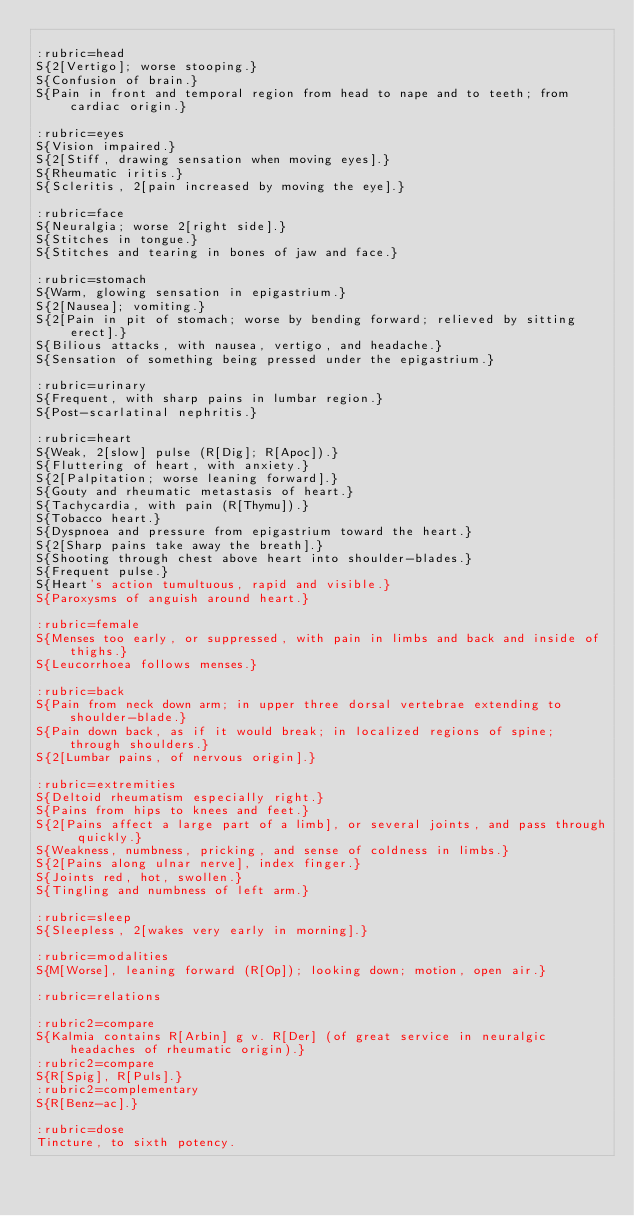<code> <loc_0><loc_0><loc_500><loc_500><_ObjectiveC_>
:rubric=head
S{2[Vertigo]; worse stooping.}
S{Confusion of brain.}
S{Pain in front and temporal region from head to nape and to teeth; from cardiac origin.}

:rubric=eyes
S{Vision impaired.}
S{2[Stiff, drawing sensation when moving eyes].}
S{Rheumatic iritis.}
S{Scleritis, 2[pain increased by moving the eye].}

:rubric=face
S{Neuralgia; worse 2[right side].}
S{Stitches in tongue.}
S{Stitches and tearing in bones of jaw and face.}

:rubric=stomach
S{Warm, glowing sensation in epigastrium.}
S{2[Nausea]; vomiting.}
S{2[Pain in pit of stomach; worse by bending forward; relieved by sitting erect].}
S{Bilious attacks, with nausea, vertigo, and headache.}
S{Sensation of something being pressed under the epigastrium.}

:rubric=urinary
S{Frequent, with sharp pains in lumbar region.}
S{Post-scarlatinal nephritis.}

:rubric=heart
S{Weak, 2[slow] pulse (R[Dig]; R[Apoc]).}
S{Fluttering of heart, with anxiety.}
S{2[Palpitation; worse leaning forward].}
S{Gouty and rheumatic metastasis of heart.}
S{Tachycardia, with pain (R[Thymu]).}
S{Tobacco heart.}
S{Dyspnoea and pressure from epigastrium toward the heart.}
S{2[Sharp pains take away the breath].}
S{Shooting through chest above heart into shoulder-blades.}
S{Frequent pulse.}
S{Heart's action tumultuous, rapid and visible.}
S{Paroxysms of anguish around heart.}

:rubric=female
S{Menses too early, or suppressed, with pain in limbs and back and inside of thighs.}
S{Leucorrhoea follows menses.}

:rubric=back
S{Pain from neck down arm; in upper three dorsal vertebrae extending to shoulder-blade.}
S{Pain down back, as if it would break; in localized regions of spine; through shoulders.}
S{2[Lumbar pains, of nervous origin].}

:rubric=extremities
S{Deltoid rheumatism especially right.}
S{Pains from hips to knees and feet.}
S{2[Pains affect a large part of a limb], or several joints, and pass through quickly.}
S{Weakness, numbness, pricking, and sense of coldness in limbs.}
S{2[Pains along ulnar nerve], index finger.}
S{Joints red, hot, swollen.}
S{Tingling and numbness of left arm.}

:rubric=sleep
S{Sleepless, 2[wakes very early in morning].}

:rubric=modalities
S{M[Worse], leaning forward (R[Op]); looking down; motion, open air.}

:rubric=relations

:rubric2=compare
S{Kalmia contains R[Arbin] g v. R[Der] (of great service in neuralgic headaches of rheumatic origin).}
:rubric2=compare
S{R[Spig], R[Puls].}
:rubric2=complementary
S{R[Benz-ac].}

:rubric=dose
Tincture, to sixth potency.</code> 